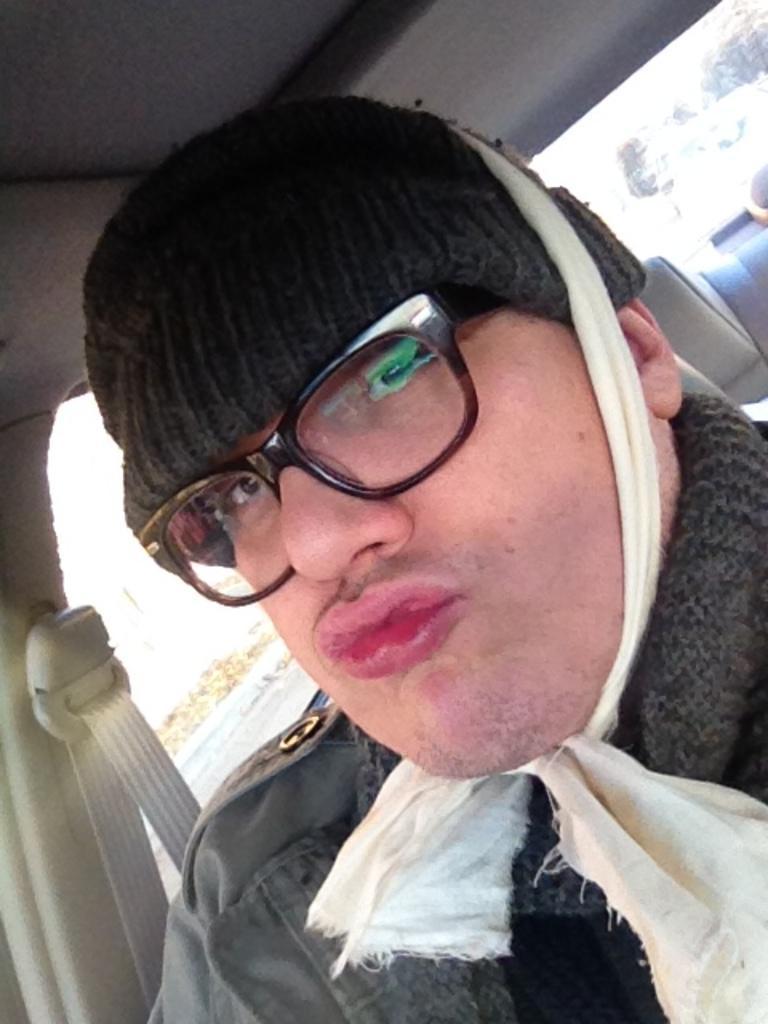Please provide a concise description of this image. In this image I can see a person wearing black cap, black dress and black spectacles is sitting in a vehicle. Through the glass of the vehicle I can see few trees and the sky. 